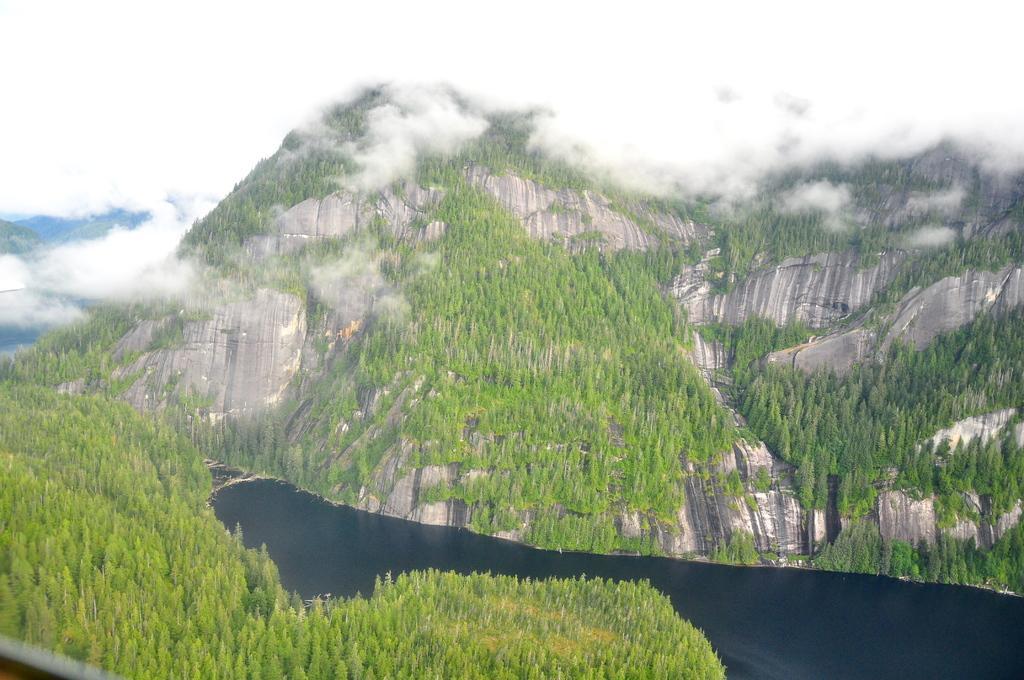Please provide a concise description of this image. In this picture there are hills covered with trees and fog. In the center, there is a river. 